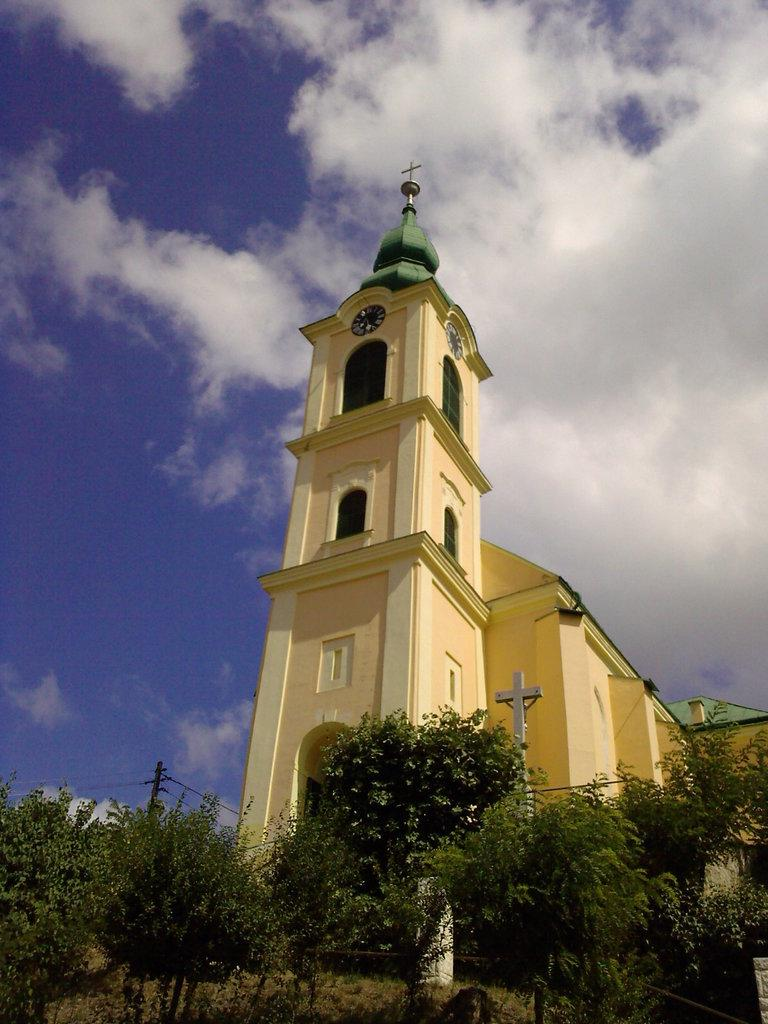What is the main structure in the center of the image? There is a church in the center of the image. What religious symbols can be seen in the image? There are crosses in the image. What type of vegetation is at the bottom of the image? There are trees at the bottom of the image. What objects are at the bottom of the image, besides trees? There is a pole and wires at the bottom of the image. What is visible at the top of the image? The sky is visible at the top of the image. What type of horn can be heard coming from the church in the image? There is no indication of any sound, including a horn, in the image. 